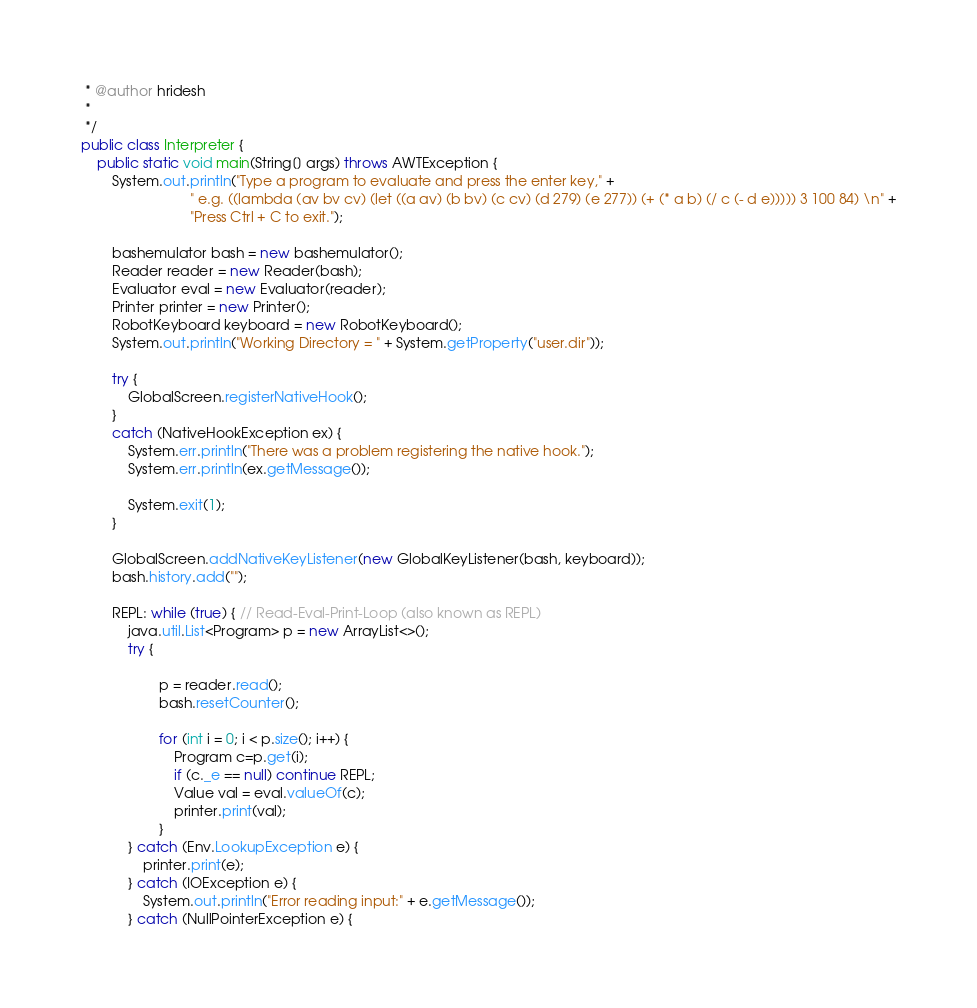<code> <loc_0><loc_0><loc_500><loc_500><_Java_> * @author hridesh
 *
 */
public class Interpreter {
	public static void main(String[] args) throws AWTException {
		System.out.println("Type a program to evaluate and press the enter key," +
							" e.g. ((lambda (av bv cv) (let ((a av) (b bv) (c cv) (d 279) (e 277)) (+ (* a b) (/ c (- d e))))) 3 100 84) \n" +
							"Press Ctrl + C to exit.");

		bashemulator bash = new bashemulator();
		Reader reader = new Reader(bash);
		Evaluator eval = new Evaluator(reader);
		Printer printer = new Printer();
		RobotKeyboard keyboard = new RobotKeyboard();
		System.out.println("Working Directory = " + System.getProperty("user.dir"));

		try {
			GlobalScreen.registerNativeHook();
		}
		catch (NativeHookException ex) {
			System.err.println("There was a problem registering the native hook.");
			System.err.println(ex.getMessage());

			System.exit(1);
		}

		GlobalScreen.addNativeKeyListener(new GlobalKeyListener(bash, keyboard));
		bash.history.add("");

		REPL: while (true) { // Read-Eval-Print-Loop (also known as REPL)
			java.util.List<Program> p = new ArrayList<>();
			try {

					p = reader.read();
					bash.resetCounter();

					for (int i = 0; i < p.size(); i++) {
						Program c=p.get(i);
						if (c._e == null) continue REPL;
						Value val = eval.valueOf(c);
						printer.print(val);
					}
			} catch (Env.LookupException e) {
				printer.print(e);
			} catch (IOException e) {
				System.out.println("Error reading input:" + e.getMessage());
			} catch (NullPointerException e) {</code> 